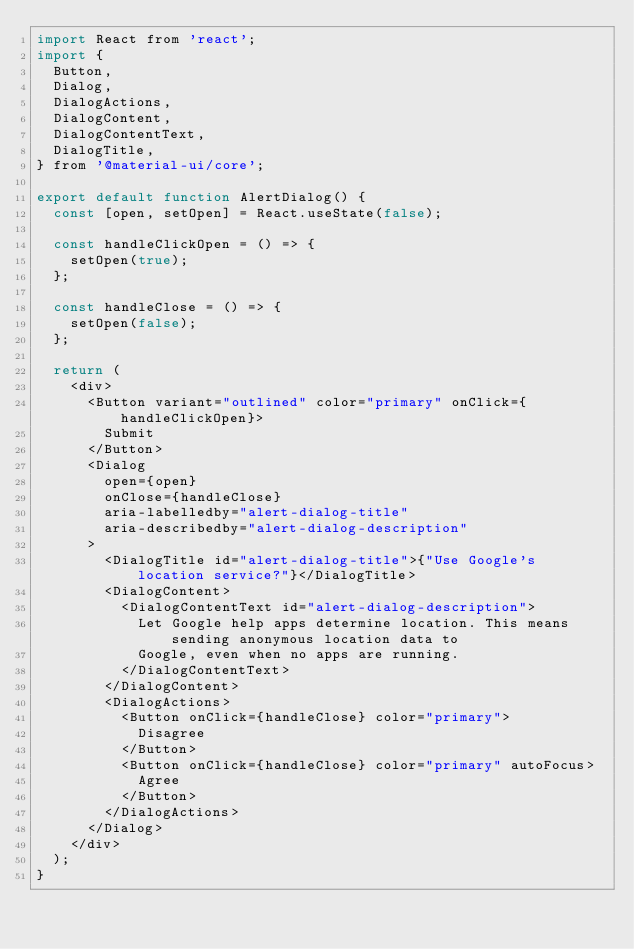Convert code to text. <code><loc_0><loc_0><loc_500><loc_500><_JavaScript_>import React from 'react';
import {
  Button,
  Dialog,
  DialogActions,
  DialogContent,
  DialogContentText,
  DialogTitle,
} from '@material-ui/core';

export default function AlertDialog() {
  const [open, setOpen] = React.useState(false);

  const handleClickOpen = () => {
    setOpen(true);
  };

  const handleClose = () => {
    setOpen(false);
  };

  return (
    <div>
      <Button variant="outlined" color="primary" onClick={handleClickOpen}>
        Submit
      </Button>
      <Dialog
        open={open}
        onClose={handleClose}
        aria-labelledby="alert-dialog-title"
        aria-describedby="alert-dialog-description"
      >
        <DialogTitle id="alert-dialog-title">{"Use Google's location service?"}</DialogTitle>
        <DialogContent>
          <DialogContentText id="alert-dialog-description">
            Let Google help apps determine location. This means sending anonymous location data to
            Google, even when no apps are running.
          </DialogContentText>
        </DialogContent>
        <DialogActions>
          <Button onClick={handleClose} color="primary">
            Disagree
          </Button>
          <Button onClick={handleClose} color="primary" autoFocus>
            Agree
          </Button>
        </DialogActions>
      </Dialog>
    </div>
  );
}
</code> 